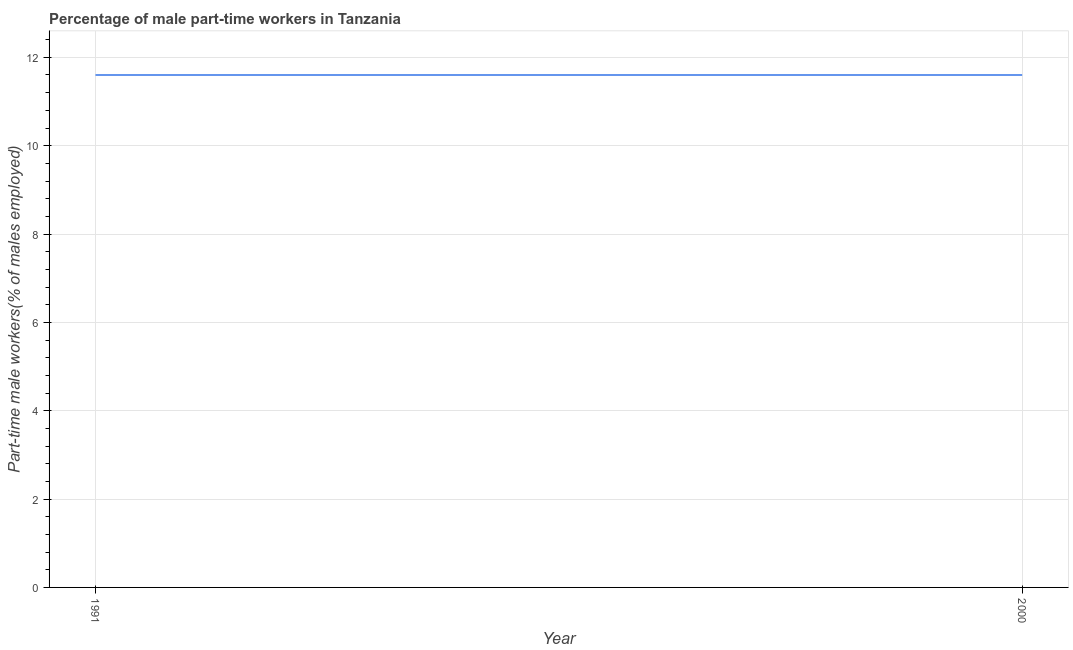What is the percentage of part-time male workers in 1991?
Ensure brevity in your answer.  11.6. Across all years, what is the maximum percentage of part-time male workers?
Ensure brevity in your answer.  11.6. Across all years, what is the minimum percentage of part-time male workers?
Provide a succinct answer. 11.6. In which year was the percentage of part-time male workers maximum?
Your answer should be compact. 1991. In which year was the percentage of part-time male workers minimum?
Your answer should be compact. 1991. What is the sum of the percentage of part-time male workers?
Offer a very short reply. 23.2. What is the average percentage of part-time male workers per year?
Provide a succinct answer. 11.6. What is the median percentage of part-time male workers?
Provide a short and direct response. 11.6. What is the ratio of the percentage of part-time male workers in 1991 to that in 2000?
Offer a terse response. 1. Is the percentage of part-time male workers in 1991 less than that in 2000?
Offer a terse response. No. Does the percentage of part-time male workers monotonically increase over the years?
Your answer should be very brief. No. How many lines are there?
Give a very brief answer. 1. How many years are there in the graph?
Make the answer very short. 2. What is the difference between two consecutive major ticks on the Y-axis?
Provide a short and direct response. 2. Are the values on the major ticks of Y-axis written in scientific E-notation?
Offer a very short reply. No. Does the graph contain any zero values?
Keep it short and to the point. No. Does the graph contain grids?
Offer a very short reply. Yes. What is the title of the graph?
Ensure brevity in your answer.  Percentage of male part-time workers in Tanzania. What is the label or title of the Y-axis?
Your answer should be compact. Part-time male workers(% of males employed). What is the Part-time male workers(% of males employed) in 1991?
Offer a terse response. 11.6. What is the Part-time male workers(% of males employed) in 2000?
Keep it short and to the point. 11.6. 